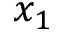<formula> <loc_0><loc_0><loc_500><loc_500>x _ { 1 }</formula> 